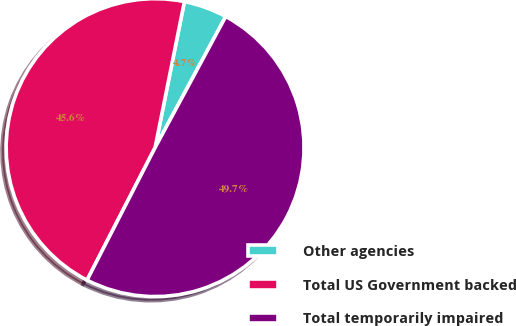<chart> <loc_0><loc_0><loc_500><loc_500><pie_chart><fcel>Other agencies<fcel>Total US Government backed<fcel>Total temporarily impaired<nl><fcel>4.71%<fcel>45.6%<fcel>49.69%<nl></chart> 